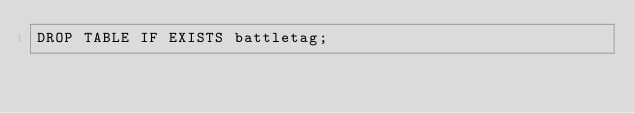Convert code to text. <code><loc_0><loc_0><loc_500><loc_500><_SQL_>DROP TABLE IF EXISTS battletag;</code> 